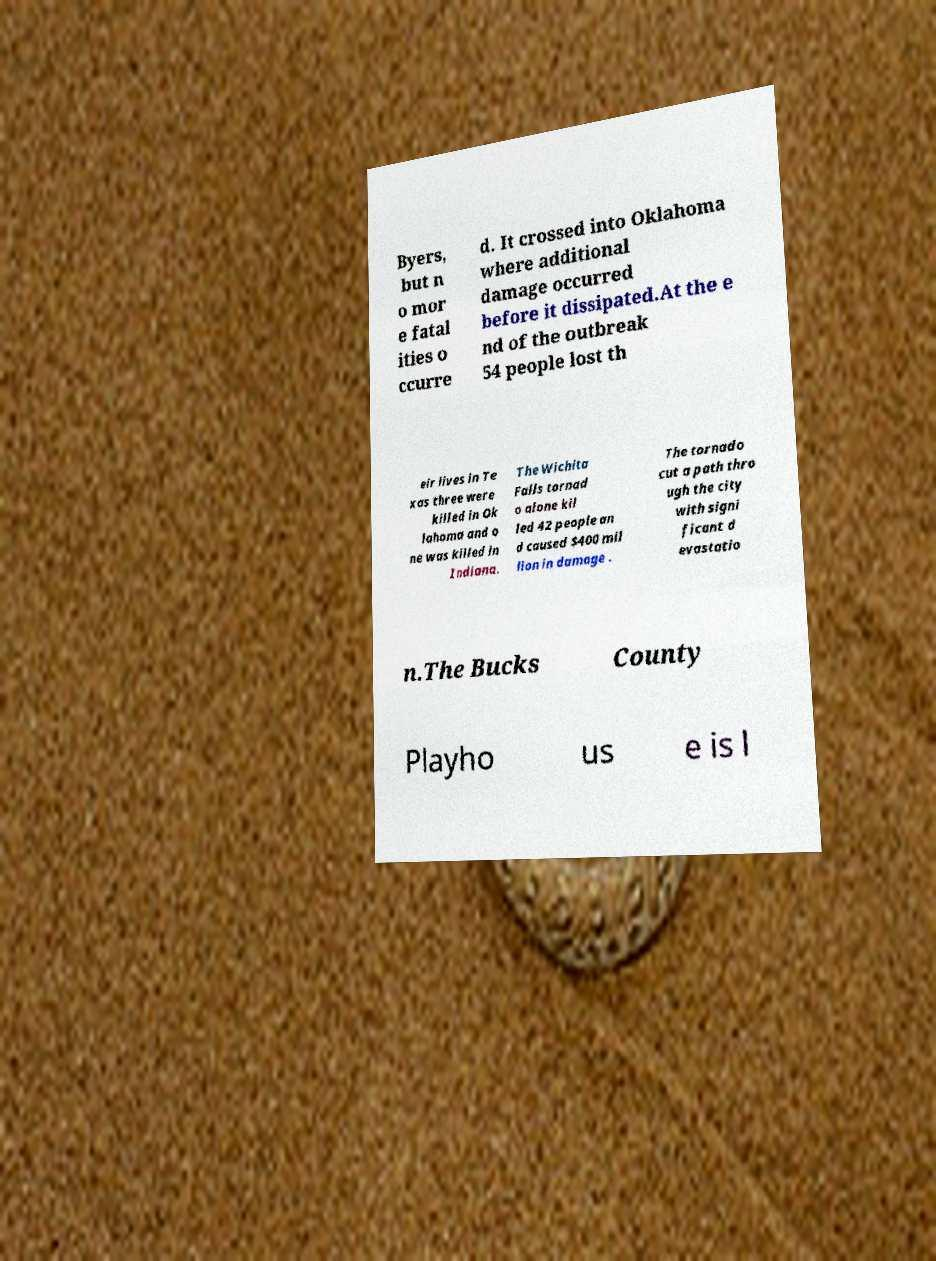Could you assist in decoding the text presented in this image and type it out clearly? Byers, but n o mor e fatal ities o ccurre d. It crossed into Oklahoma where additional damage occurred before it dissipated.At the e nd of the outbreak 54 people lost th eir lives in Te xas three were killed in Ok lahoma and o ne was killed in Indiana. The Wichita Falls tornad o alone kil led 42 people an d caused $400 mil lion in damage . The tornado cut a path thro ugh the city with signi ficant d evastatio n.The Bucks County Playho us e is l 